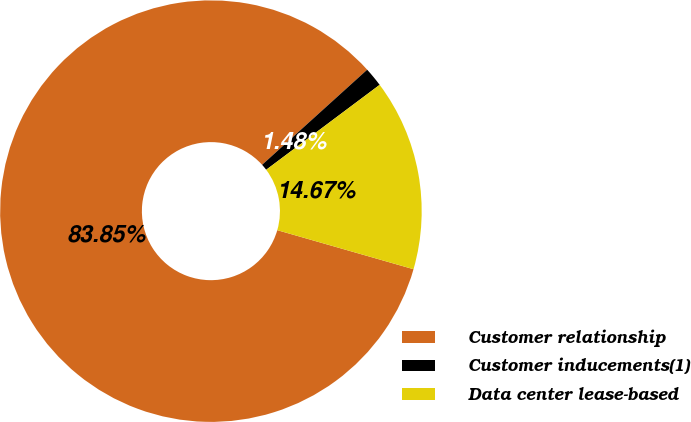Convert chart to OTSL. <chart><loc_0><loc_0><loc_500><loc_500><pie_chart><fcel>Customer relationship<fcel>Customer inducements(1)<fcel>Data center lease-based<nl><fcel>83.85%<fcel>1.48%<fcel>14.67%<nl></chart> 